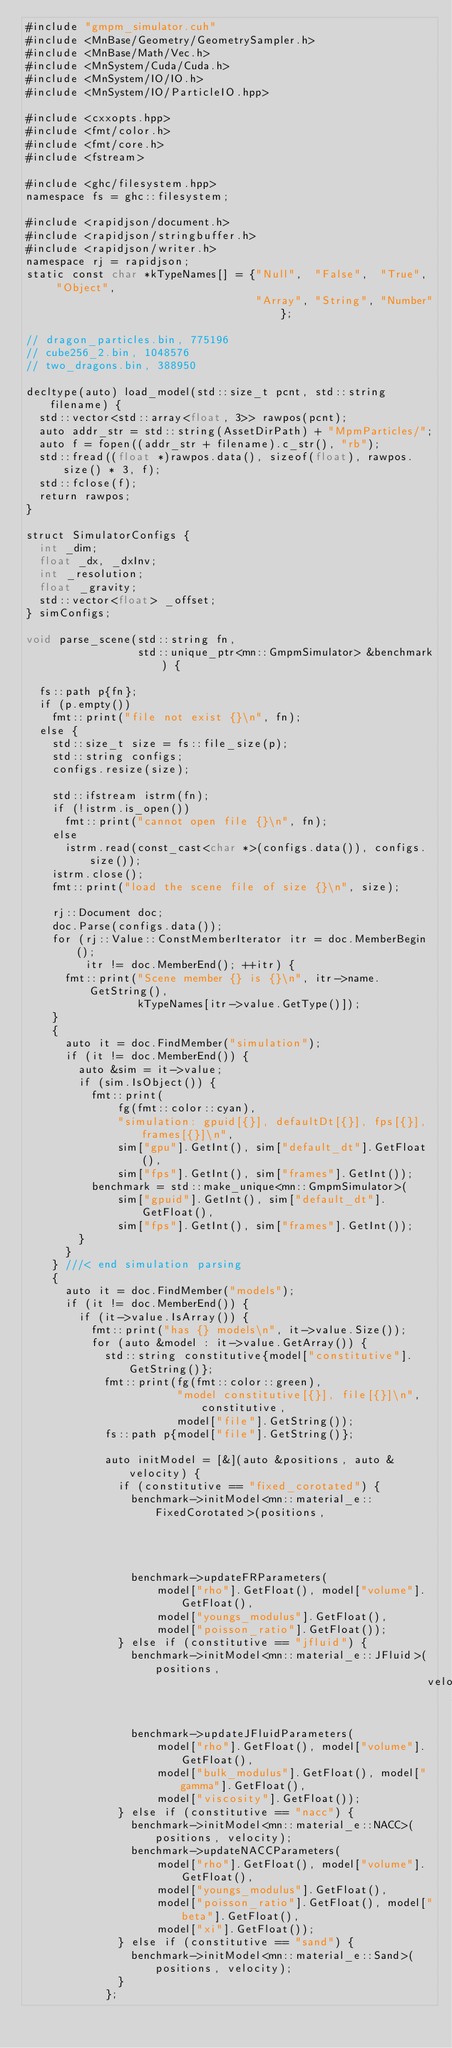Convert code to text. <code><loc_0><loc_0><loc_500><loc_500><_Cuda_>#include "gmpm_simulator.cuh"
#include <MnBase/Geometry/GeometrySampler.h>
#include <MnBase/Math/Vec.h>
#include <MnSystem/Cuda/Cuda.h>
#include <MnSystem/IO/IO.h>
#include <MnSystem/IO/ParticleIO.hpp>

#include <cxxopts.hpp>
#include <fmt/color.h>
#include <fmt/core.h>
#include <fstream>

#include <ghc/filesystem.hpp>
namespace fs = ghc::filesystem;

#include <rapidjson/document.h>
#include <rapidjson/stringbuffer.h>
#include <rapidjson/writer.h>
namespace rj = rapidjson;
static const char *kTypeNames[] = {"Null",  "False",  "True",  "Object",
                                   "Array", "String", "Number"};

// dragon_particles.bin, 775196
// cube256_2.bin, 1048576
// two_dragons.bin, 388950

decltype(auto) load_model(std::size_t pcnt, std::string filename) {
  std::vector<std::array<float, 3>> rawpos(pcnt);
  auto addr_str = std::string(AssetDirPath) + "MpmParticles/";
  auto f = fopen((addr_str + filename).c_str(), "rb");
  std::fread((float *)rawpos.data(), sizeof(float), rawpos.size() * 3, f);
  std::fclose(f);
  return rawpos;
}

struct SimulatorConfigs {
  int _dim;
  float _dx, _dxInv;
  int _resolution;
  float _gravity;
  std::vector<float> _offset;
} simConfigs;

void parse_scene(std::string fn,
                 std::unique_ptr<mn::GmpmSimulator> &benchmark) {

  fs::path p{fn};
  if (p.empty())
    fmt::print("file not exist {}\n", fn);
  else {
    std::size_t size = fs::file_size(p);
    std::string configs;
    configs.resize(size);

    std::ifstream istrm(fn);
    if (!istrm.is_open())
      fmt::print("cannot open file {}\n", fn);
    else
      istrm.read(const_cast<char *>(configs.data()), configs.size());
    istrm.close();
    fmt::print("load the scene file of size {}\n", size);

    rj::Document doc;
    doc.Parse(configs.data());
    for (rj::Value::ConstMemberIterator itr = doc.MemberBegin();
         itr != doc.MemberEnd(); ++itr) {
      fmt::print("Scene member {} is {}\n", itr->name.GetString(),
                 kTypeNames[itr->value.GetType()]);
    }
    {
      auto it = doc.FindMember("simulation");
      if (it != doc.MemberEnd()) {
        auto &sim = it->value;
        if (sim.IsObject()) {
          fmt::print(
              fg(fmt::color::cyan),
              "simulation: gpuid[{}], defaultDt[{}], fps[{}], frames[{}]\n",
              sim["gpu"].GetInt(), sim["default_dt"].GetFloat(),
              sim["fps"].GetInt(), sim["frames"].GetInt());
          benchmark = std::make_unique<mn::GmpmSimulator>(
              sim["gpuid"].GetInt(), sim["default_dt"].GetFloat(),
              sim["fps"].GetInt(), sim["frames"].GetInt());
        }
      }
    } ///< end simulation parsing
    {
      auto it = doc.FindMember("models");
      if (it != doc.MemberEnd()) {
        if (it->value.IsArray()) {
          fmt::print("has {} models\n", it->value.Size());
          for (auto &model : it->value.GetArray()) {
            std::string constitutive{model["constitutive"].GetString()};
            fmt::print(fg(fmt::color::green),
                       "model constitutive[{}], file[{}]\n", constitutive,
                       model["file"].GetString());
            fs::path p{model["file"].GetString()};

            auto initModel = [&](auto &positions, auto &velocity) {
              if (constitutive == "fixed_corotated") {
                benchmark->initModel<mn::material_e::FixedCorotated>(positions,
                                                                     velocity);
                benchmark->updateFRParameters(
                    model["rho"].GetFloat(), model["volume"].GetFloat(),
                    model["youngs_modulus"].GetFloat(),
                    model["poisson_ratio"].GetFloat());
              } else if (constitutive == "jfluid") {
                benchmark->initModel<mn::material_e::JFluid>(positions,
                                                             velocity);
                benchmark->updateJFluidParameters(
                    model["rho"].GetFloat(), model["volume"].GetFloat(),
                    model["bulk_modulus"].GetFloat(), model["gamma"].GetFloat(),
                    model["viscosity"].GetFloat());
              } else if (constitutive == "nacc") {
                benchmark->initModel<mn::material_e::NACC>(positions, velocity);
                benchmark->updateNACCParameters(
                    model["rho"].GetFloat(), model["volume"].GetFloat(),
                    model["youngs_modulus"].GetFloat(),
                    model["poisson_ratio"].GetFloat(), model["beta"].GetFloat(),
                    model["xi"].GetFloat());
              } else if (constitutive == "sand") {
                benchmark->initModel<mn::material_e::Sand>(positions, velocity);
              }
            };</code> 